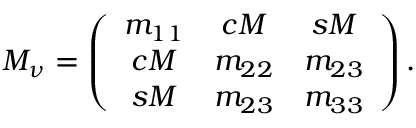<formula> <loc_0><loc_0><loc_500><loc_500>M _ { \nu } = \left ( \begin{array} { c c c } { { m _ { 1 1 } } } & { c M } & { s M } \\ { c M } & { { m _ { 2 2 } } } & { { m _ { 2 3 } } } \\ { s M } & { { m _ { 2 3 } } } & { { m _ { 3 3 } } } \end{array} \right ) .</formula> 